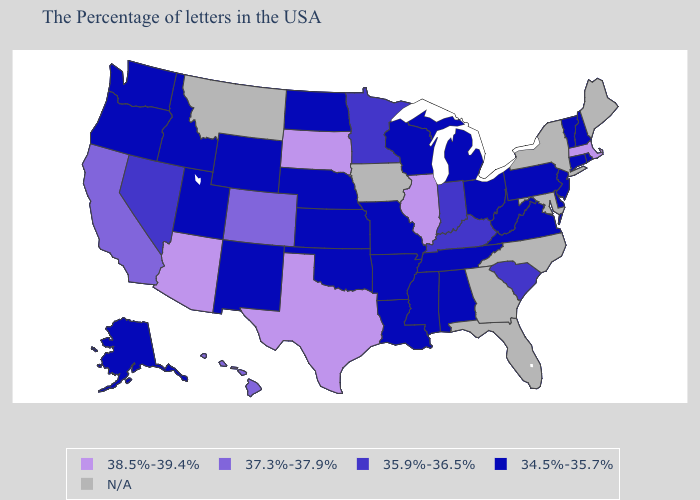What is the value of Louisiana?
Keep it brief. 34.5%-35.7%. Name the states that have a value in the range 38.5%-39.4%?
Be succinct. Massachusetts, Illinois, Texas, South Dakota, Arizona. What is the highest value in states that border Colorado?
Write a very short answer. 38.5%-39.4%. What is the value of Nevada?
Short answer required. 35.9%-36.5%. What is the lowest value in the West?
Give a very brief answer. 34.5%-35.7%. What is the highest value in the South ?
Write a very short answer. 38.5%-39.4%. Name the states that have a value in the range 37.3%-37.9%?
Be succinct. Colorado, California, Hawaii. How many symbols are there in the legend?
Write a very short answer. 5. What is the lowest value in the USA?
Give a very brief answer. 34.5%-35.7%. How many symbols are there in the legend?
Answer briefly. 5. Which states have the lowest value in the Northeast?
Be succinct. Rhode Island, New Hampshire, Vermont, Connecticut, New Jersey, Pennsylvania. Does South Dakota have the highest value in the USA?
Concise answer only. Yes. Name the states that have a value in the range 34.5%-35.7%?
Short answer required. Rhode Island, New Hampshire, Vermont, Connecticut, New Jersey, Delaware, Pennsylvania, Virginia, West Virginia, Ohio, Michigan, Alabama, Tennessee, Wisconsin, Mississippi, Louisiana, Missouri, Arkansas, Kansas, Nebraska, Oklahoma, North Dakota, Wyoming, New Mexico, Utah, Idaho, Washington, Oregon, Alaska. 